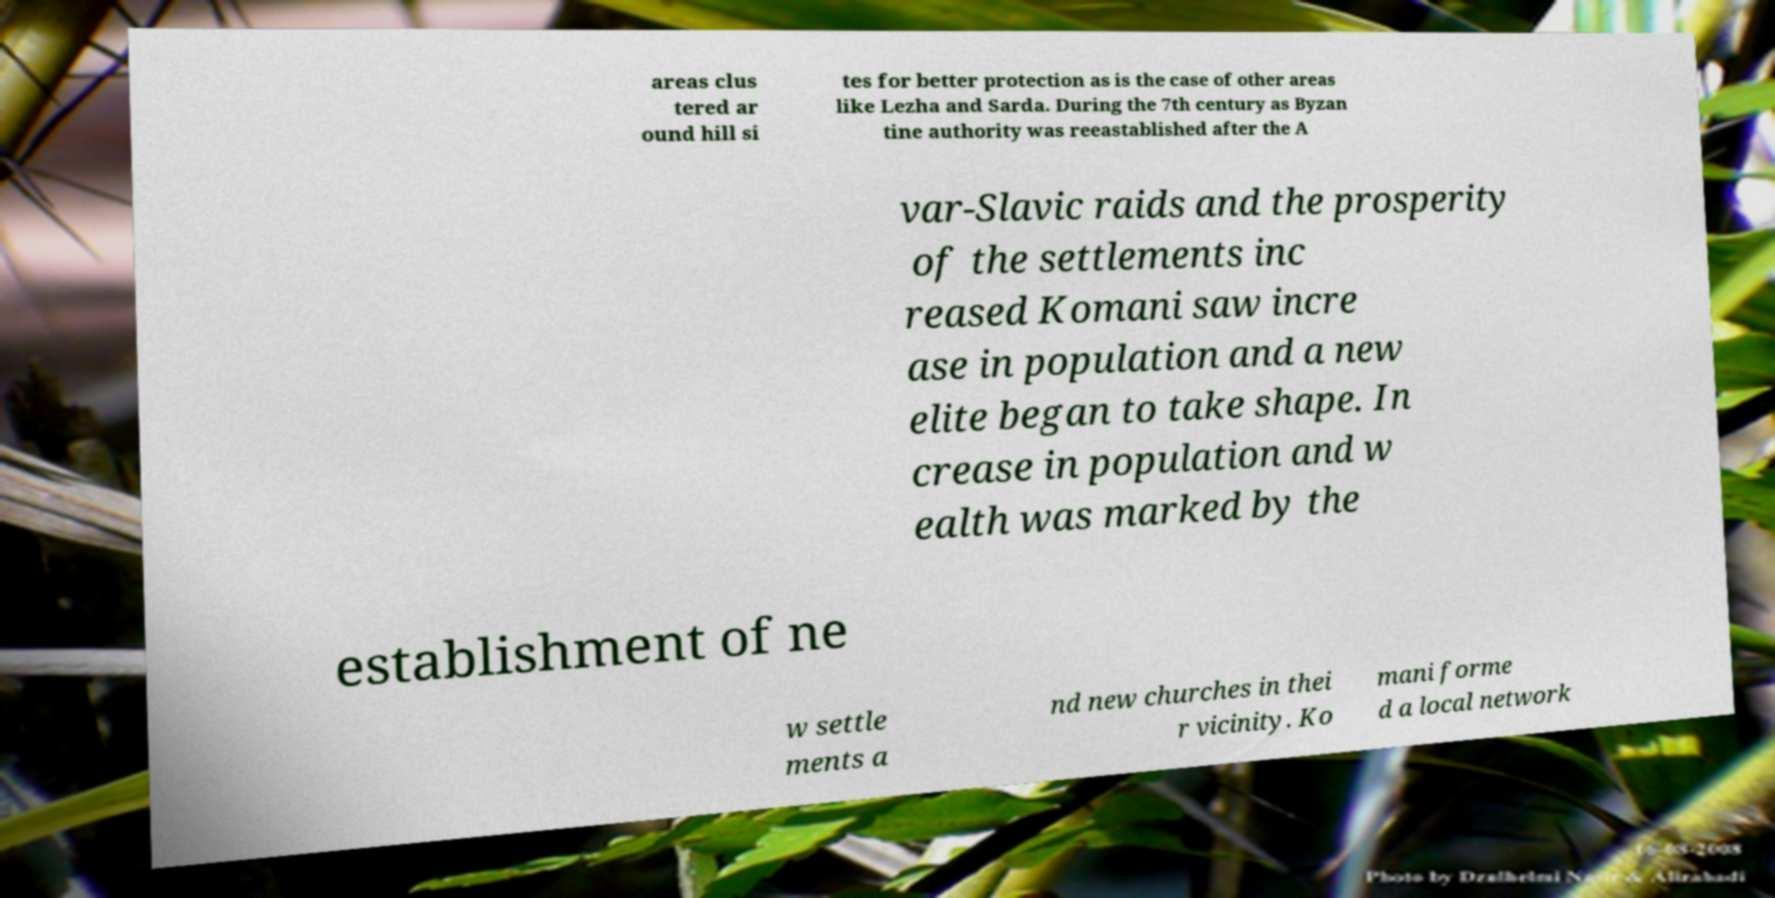Can you read and provide the text displayed in the image?This photo seems to have some interesting text. Can you extract and type it out for me? areas clus tered ar ound hill si tes for better protection as is the case of other areas like Lezha and Sarda. During the 7th century as Byzan tine authority was reeastablished after the A var-Slavic raids and the prosperity of the settlements inc reased Komani saw incre ase in population and a new elite began to take shape. In crease in population and w ealth was marked by the establishment of ne w settle ments a nd new churches in thei r vicinity. Ko mani forme d a local network 